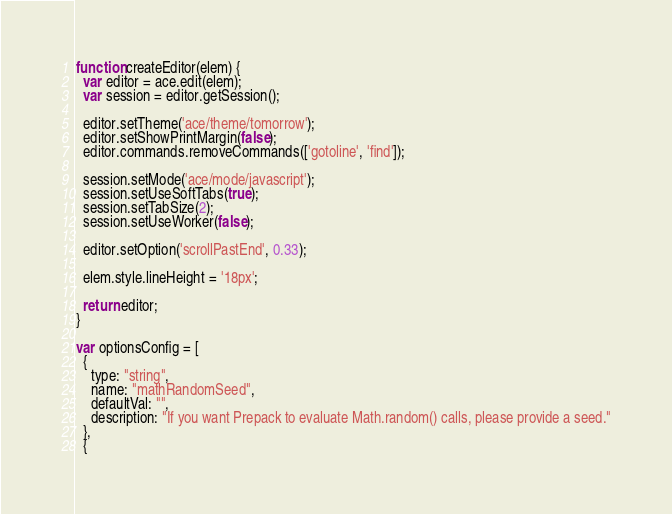Convert code to text. <code><loc_0><loc_0><loc_500><loc_500><_JavaScript_>function createEditor(elem) {
  var editor = ace.edit(elem);
  var session = editor.getSession();

  editor.setTheme('ace/theme/tomorrow');
  editor.setShowPrintMargin(false);
  editor.commands.removeCommands(['gotoline', 'find']);

  session.setMode('ace/mode/javascript');
  session.setUseSoftTabs(true);
  session.setTabSize(2);
  session.setUseWorker(false);

  editor.setOption('scrollPastEnd', 0.33);

  elem.style.lineHeight = '18px';

  return editor;
}

var optionsConfig = [
  {
    type: "string",
    name: "mathRandomSeed",
    defaultVal: "",
    description: "If you want Prepack to evaluate Math.random() calls, please provide a seed."
  },
  {</code> 